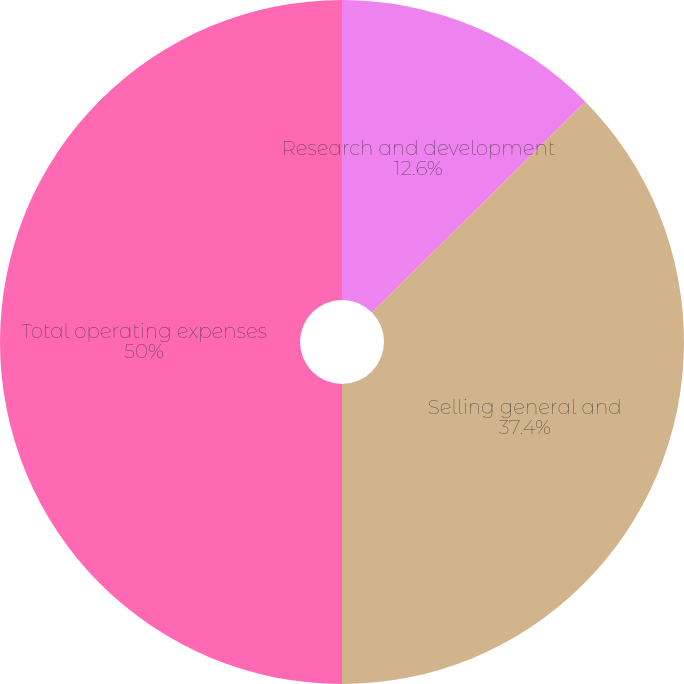<chart> <loc_0><loc_0><loc_500><loc_500><pie_chart><fcel>Research and development<fcel>Selling general and<fcel>Total operating expenses<nl><fcel>12.6%<fcel>37.4%<fcel>50.0%<nl></chart> 